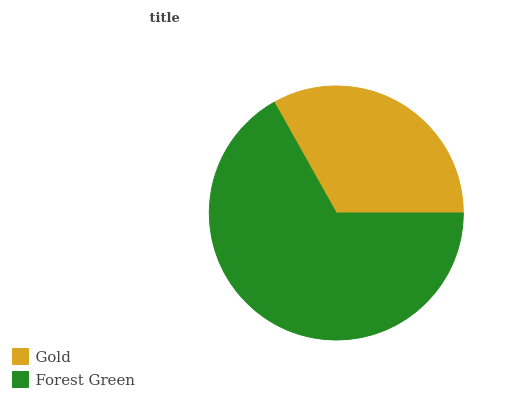Is Gold the minimum?
Answer yes or no. Yes. Is Forest Green the maximum?
Answer yes or no. Yes. Is Forest Green the minimum?
Answer yes or no. No. Is Forest Green greater than Gold?
Answer yes or no. Yes. Is Gold less than Forest Green?
Answer yes or no. Yes. Is Gold greater than Forest Green?
Answer yes or no. No. Is Forest Green less than Gold?
Answer yes or no. No. Is Forest Green the high median?
Answer yes or no. Yes. Is Gold the low median?
Answer yes or no. Yes. Is Gold the high median?
Answer yes or no. No. Is Forest Green the low median?
Answer yes or no. No. 